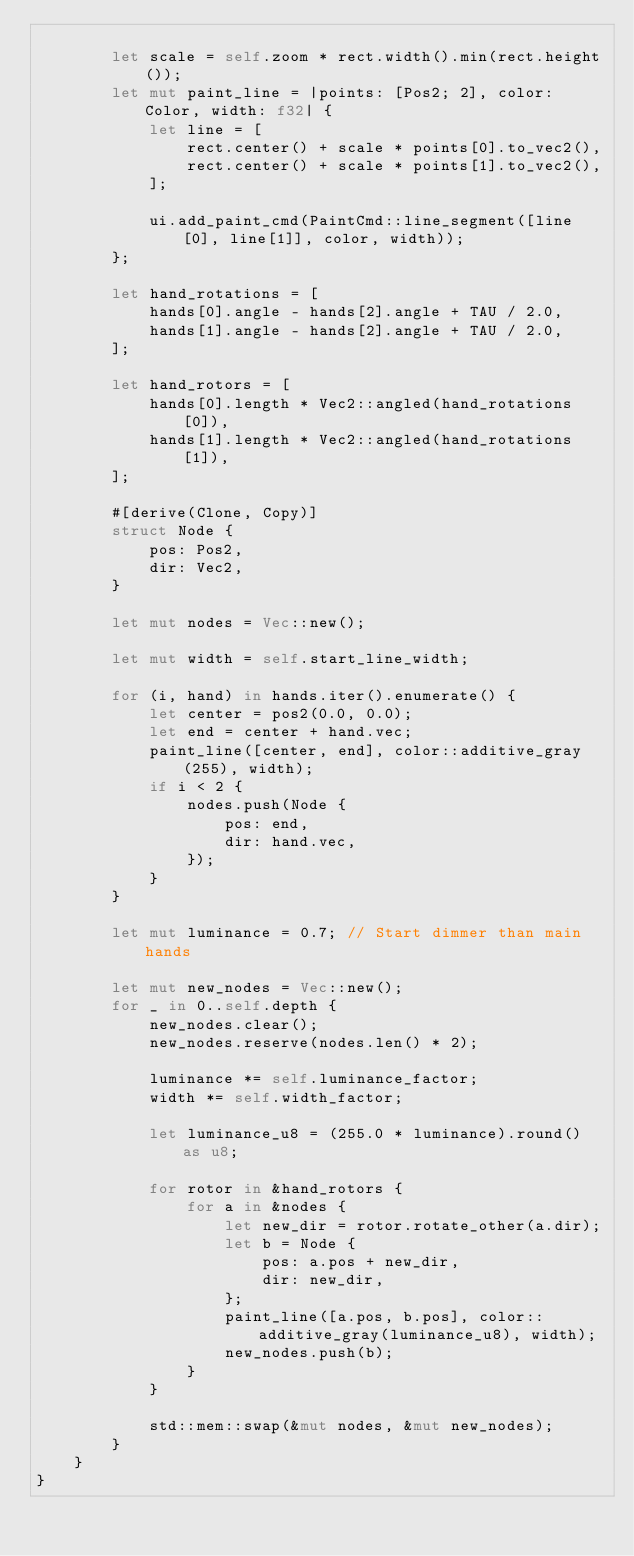Convert code to text. <code><loc_0><loc_0><loc_500><loc_500><_Rust_>
        let scale = self.zoom * rect.width().min(rect.height());
        let mut paint_line = |points: [Pos2; 2], color: Color, width: f32| {
            let line = [
                rect.center() + scale * points[0].to_vec2(),
                rect.center() + scale * points[1].to_vec2(),
            ];

            ui.add_paint_cmd(PaintCmd::line_segment([line[0], line[1]], color, width));
        };

        let hand_rotations = [
            hands[0].angle - hands[2].angle + TAU / 2.0,
            hands[1].angle - hands[2].angle + TAU / 2.0,
        ];

        let hand_rotors = [
            hands[0].length * Vec2::angled(hand_rotations[0]),
            hands[1].length * Vec2::angled(hand_rotations[1]),
        ];

        #[derive(Clone, Copy)]
        struct Node {
            pos: Pos2,
            dir: Vec2,
        }

        let mut nodes = Vec::new();

        let mut width = self.start_line_width;

        for (i, hand) in hands.iter().enumerate() {
            let center = pos2(0.0, 0.0);
            let end = center + hand.vec;
            paint_line([center, end], color::additive_gray(255), width);
            if i < 2 {
                nodes.push(Node {
                    pos: end,
                    dir: hand.vec,
                });
            }
        }

        let mut luminance = 0.7; // Start dimmer than main hands

        let mut new_nodes = Vec::new();
        for _ in 0..self.depth {
            new_nodes.clear();
            new_nodes.reserve(nodes.len() * 2);

            luminance *= self.luminance_factor;
            width *= self.width_factor;

            let luminance_u8 = (255.0 * luminance).round() as u8;

            for rotor in &hand_rotors {
                for a in &nodes {
                    let new_dir = rotor.rotate_other(a.dir);
                    let b = Node {
                        pos: a.pos + new_dir,
                        dir: new_dir,
                    };
                    paint_line([a.pos, b.pos], color::additive_gray(luminance_u8), width);
                    new_nodes.push(b);
                }
            }

            std::mem::swap(&mut nodes, &mut new_nodes);
        }
    }
}
</code> 